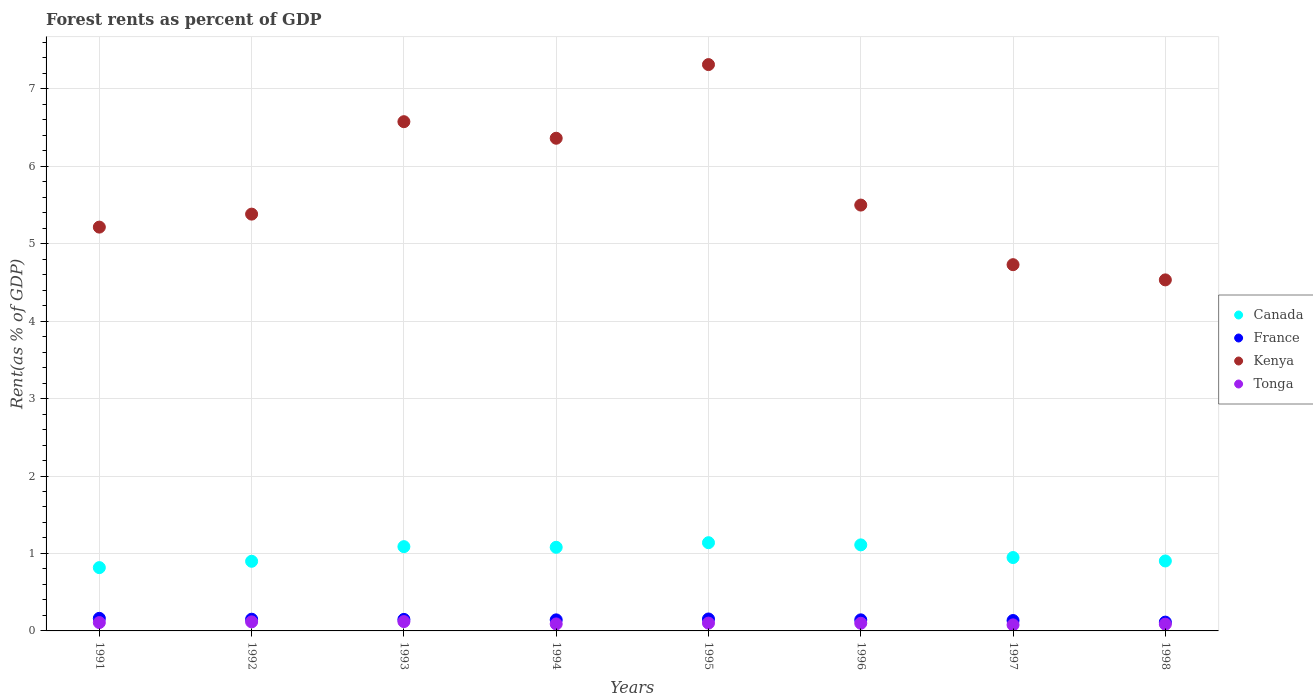Is the number of dotlines equal to the number of legend labels?
Provide a succinct answer. Yes. What is the forest rent in Canada in 1993?
Make the answer very short. 1.09. Across all years, what is the maximum forest rent in Kenya?
Your answer should be compact. 7.31. Across all years, what is the minimum forest rent in Kenya?
Offer a terse response. 4.53. In which year was the forest rent in Canada maximum?
Offer a terse response. 1995. What is the total forest rent in Kenya in the graph?
Offer a very short reply. 45.6. What is the difference between the forest rent in Kenya in 1993 and that in 1996?
Your answer should be compact. 1.08. What is the difference between the forest rent in Canada in 1992 and the forest rent in Kenya in 1996?
Offer a terse response. -4.6. What is the average forest rent in France per year?
Keep it short and to the point. 0.14. In the year 1997, what is the difference between the forest rent in Kenya and forest rent in France?
Provide a short and direct response. 4.59. What is the ratio of the forest rent in Kenya in 1996 to that in 1998?
Offer a very short reply. 1.21. Is the difference between the forest rent in Kenya in 1992 and 1994 greater than the difference between the forest rent in France in 1992 and 1994?
Ensure brevity in your answer.  No. What is the difference between the highest and the second highest forest rent in France?
Provide a succinct answer. 0.01. What is the difference between the highest and the lowest forest rent in France?
Offer a terse response. 0.05. In how many years, is the forest rent in Canada greater than the average forest rent in Canada taken over all years?
Offer a terse response. 4. Does the forest rent in Canada monotonically increase over the years?
Provide a succinct answer. No. Is the forest rent in Tonga strictly less than the forest rent in Canada over the years?
Provide a short and direct response. Yes. How many years are there in the graph?
Provide a short and direct response. 8. What is the difference between two consecutive major ticks on the Y-axis?
Your answer should be compact. 1. How many legend labels are there?
Your answer should be compact. 4. How are the legend labels stacked?
Your answer should be very brief. Vertical. What is the title of the graph?
Offer a very short reply. Forest rents as percent of GDP. What is the label or title of the X-axis?
Offer a very short reply. Years. What is the label or title of the Y-axis?
Your response must be concise. Rent(as % of GDP). What is the Rent(as % of GDP) in Canada in 1991?
Offer a very short reply. 0.82. What is the Rent(as % of GDP) in France in 1991?
Provide a short and direct response. 0.16. What is the Rent(as % of GDP) in Kenya in 1991?
Keep it short and to the point. 5.21. What is the Rent(as % of GDP) of Tonga in 1991?
Provide a short and direct response. 0.11. What is the Rent(as % of GDP) of Canada in 1992?
Provide a short and direct response. 0.9. What is the Rent(as % of GDP) in France in 1992?
Your answer should be very brief. 0.15. What is the Rent(as % of GDP) of Kenya in 1992?
Your answer should be very brief. 5.38. What is the Rent(as % of GDP) in Tonga in 1992?
Your answer should be compact. 0.12. What is the Rent(as % of GDP) in Canada in 1993?
Offer a very short reply. 1.09. What is the Rent(as % of GDP) of France in 1993?
Give a very brief answer. 0.15. What is the Rent(as % of GDP) of Kenya in 1993?
Keep it short and to the point. 6.57. What is the Rent(as % of GDP) of Tonga in 1993?
Make the answer very short. 0.12. What is the Rent(as % of GDP) of Canada in 1994?
Offer a terse response. 1.08. What is the Rent(as % of GDP) of France in 1994?
Your answer should be compact. 0.14. What is the Rent(as % of GDP) in Kenya in 1994?
Make the answer very short. 6.36. What is the Rent(as % of GDP) of Tonga in 1994?
Offer a very short reply. 0.09. What is the Rent(as % of GDP) of Canada in 1995?
Offer a terse response. 1.14. What is the Rent(as % of GDP) in France in 1995?
Your answer should be very brief. 0.15. What is the Rent(as % of GDP) of Kenya in 1995?
Give a very brief answer. 7.31. What is the Rent(as % of GDP) of Tonga in 1995?
Your answer should be very brief. 0.1. What is the Rent(as % of GDP) in Canada in 1996?
Offer a terse response. 1.11. What is the Rent(as % of GDP) in France in 1996?
Your response must be concise. 0.14. What is the Rent(as % of GDP) in Kenya in 1996?
Offer a very short reply. 5.5. What is the Rent(as % of GDP) of Tonga in 1996?
Your answer should be compact. 0.1. What is the Rent(as % of GDP) in Canada in 1997?
Offer a very short reply. 0.95. What is the Rent(as % of GDP) of France in 1997?
Provide a succinct answer. 0.13. What is the Rent(as % of GDP) in Kenya in 1997?
Your response must be concise. 4.73. What is the Rent(as % of GDP) in Tonga in 1997?
Make the answer very short. 0.08. What is the Rent(as % of GDP) in Canada in 1998?
Ensure brevity in your answer.  0.9. What is the Rent(as % of GDP) in France in 1998?
Make the answer very short. 0.11. What is the Rent(as % of GDP) in Kenya in 1998?
Provide a succinct answer. 4.53. What is the Rent(as % of GDP) of Tonga in 1998?
Make the answer very short. 0.09. Across all years, what is the maximum Rent(as % of GDP) of Canada?
Give a very brief answer. 1.14. Across all years, what is the maximum Rent(as % of GDP) in France?
Your answer should be compact. 0.16. Across all years, what is the maximum Rent(as % of GDP) in Kenya?
Make the answer very short. 7.31. Across all years, what is the maximum Rent(as % of GDP) in Tonga?
Offer a very short reply. 0.12. Across all years, what is the minimum Rent(as % of GDP) of Canada?
Provide a succinct answer. 0.82. Across all years, what is the minimum Rent(as % of GDP) in France?
Ensure brevity in your answer.  0.11. Across all years, what is the minimum Rent(as % of GDP) in Kenya?
Your response must be concise. 4.53. Across all years, what is the minimum Rent(as % of GDP) in Tonga?
Keep it short and to the point. 0.08. What is the total Rent(as % of GDP) of Canada in the graph?
Offer a terse response. 7.98. What is the total Rent(as % of GDP) in France in the graph?
Offer a very short reply. 1.15. What is the total Rent(as % of GDP) of Kenya in the graph?
Provide a succinct answer. 45.6. What is the total Rent(as % of GDP) in Tonga in the graph?
Your answer should be compact. 0.8. What is the difference between the Rent(as % of GDP) of Canada in 1991 and that in 1992?
Ensure brevity in your answer.  -0.08. What is the difference between the Rent(as % of GDP) of France in 1991 and that in 1992?
Provide a succinct answer. 0.01. What is the difference between the Rent(as % of GDP) of Kenya in 1991 and that in 1992?
Your response must be concise. -0.17. What is the difference between the Rent(as % of GDP) of Tonga in 1991 and that in 1992?
Provide a succinct answer. -0.01. What is the difference between the Rent(as % of GDP) in Canada in 1991 and that in 1993?
Ensure brevity in your answer.  -0.27. What is the difference between the Rent(as % of GDP) in France in 1991 and that in 1993?
Offer a terse response. 0.01. What is the difference between the Rent(as % of GDP) of Kenya in 1991 and that in 1993?
Offer a very short reply. -1.36. What is the difference between the Rent(as % of GDP) of Tonga in 1991 and that in 1993?
Offer a very short reply. -0.01. What is the difference between the Rent(as % of GDP) in Canada in 1991 and that in 1994?
Keep it short and to the point. -0.26. What is the difference between the Rent(as % of GDP) in France in 1991 and that in 1994?
Provide a succinct answer. 0.02. What is the difference between the Rent(as % of GDP) in Kenya in 1991 and that in 1994?
Ensure brevity in your answer.  -1.15. What is the difference between the Rent(as % of GDP) of Tonga in 1991 and that in 1994?
Provide a short and direct response. 0.02. What is the difference between the Rent(as % of GDP) in Canada in 1991 and that in 1995?
Give a very brief answer. -0.32. What is the difference between the Rent(as % of GDP) of France in 1991 and that in 1995?
Provide a short and direct response. 0.01. What is the difference between the Rent(as % of GDP) in Kenya in 1991 and that in 1995?
Keep it short and to the point. -2.1. What is the difference between the Rent(as % of GDP) in Tonga in 1991 and that in 1995?
Offer a very short reply. 0.01. What is the difference between the Rent(as % of GDP) of Canada in 1991 and that in 1996?
Offer a very short reply. -0.29. What is the difference between the Rent(as % of GDP) in France in 1991 and that in 1996?
Offer a terse response. 0.02. What is the difference between the Rent(as % of GDP) of Kenya in 1991 and that in 1996?
Make the answer very short. -0.28. What is the difference between the Rent(as % of GDP) of Tonga in 1991 and that in 1996?
Ensure brevity in your answer.  0.01. What is the difference between the Rent(as % of GDP) in Canada in 1991 and that in 1997?
Offer a terse response. -0.13. What is the difference between the Rent(as % of GDP) in France in 1991 and that in 1997?
Keep it short and to the point. 0.03. What is the difference between the Rent(as % of GDP) of Kenya in 1991 and that in 1997?
Make the answer very short. 0.48. What is the difference between the Rent(as % of GDP) in Tonga in 1991 and that in 1997?
Your answer should be very brief. 0.03. What is the difference between the Rent(as % of GDP) of Canada in 1991 and that in 1998?
Ensure brevity in your answer.  -0.09. What is the difference between the Rent(as % of GDP) in France in 1991 and that in 1998?
Ensure brevity in your answer.  0.05. What is the difference between the Rent(as % of GDP) in Kenya in 1991 and that in 1998?
Provide a short and direct response. 0.68. What is the difference between the Rent(as % of GDP) of Tonga in 1991 and that in 1998?
Offer a very short reply. 0.02. What is the difference between the Rent(as % of GDP) of Canada in 1992 and that in 1993?
Ensure brevity in your answer.  -0.19. What is the difference between the Rent(as % of GDP) in France in 1992 and that in 1993?
Offer a terse response. 0. What is the difference between the Rent(as % of GDP) in Kenya in 1992 and that in 1993?
Your answer should be compact. -1.19. What is the difference between the Rent(as % of GDP) of Tonga in 1992 and that in 1993?
Your answer should be very brief. -0. What is the difference between the Rent(as % of GDP) of Canada in 1992 and that in 1994?
Offer a terse response. -0.18. What is the difference between the Rent(as % of GDP) of France in 1992 and that in 1994?
Keep it short and to the point. 0.01. What is the difference between the Rent(as % of GDP) of Kenya in 1992 and that in 1994?
Offer a very short reply. -0.98. What is the difference between the Rent(as % of GDP) in Tonga in 1992 and that in 1994?
Keep it short and to the point. 0.03. What is the difference between the Rent(as % of GDP) of Canada in 1992 and that in 1995?
Provide a succinct answer. -0.24. What is the difference between the Rent(as % of GDP) in France in 1992 and that in 1995?
Offer a very short reply. -0. What is the difference between the Rent(as % of GDP) of Kenya in 1992 and that in 1995?
Your answer should be very brief. -1.93. What is the difference between the Rent(as % of GDP) in Tonga in 1992 and that in 1995?
Give a very brief answer. 0.02. What is the difference between the Rent(as % of GDP) of Canada in 1992 and that in 1996?
Your answer should be compact. -0.21. What is the difference between the Rent(as % of GDP) of France in 1992 and that in 1996?
Give a very brief answer. 0.01. What is the difference between the Rent(as % of GDP) in Kenya in 1992 and that in 1996?
Offer a very short reply. -0.12. What is the difference between the Rent(as % of GDP) in Tonga in 1992 and that in 1996?
Your response must be concise. 0.02. What is the difference between the Rent(as % of GDP) of Canada in 1992 and that in 1997?
Give a very brief answer. -0.05. What is the difference between the Rent(as % of GDP) in France in 1992 and that in 1997?
Keep it short and to the point. 0.02. What is the difference between the Rent(as % of GDP) in Kenya in 1992 and that in 1997?
Keep it short and to the point. 0.65. What is the difference between the Rent(as % of GDP) of Tonga in 1992 and that in 1997?
Offer a terse response. 0.04. What is the difference between the Rent(as % of GDP) of Canada in 1992 and that in 1998?
Offer a terse response. -0. What is the difference between the Rent(as % of GDP) of France in 1992 and that in 1998?
Offer a terse response. 0.04. What is the difference between the Rent(as % of GDP) in Kenya in 1992 and that in 1998?
Your answer should be compact. 0.85. What is the difference between the Rent(as % of GDP) in Tonga in 1992 and that in 1998?
Your response must be concise. 0.03. What is the difference between the Rent(as % of GDP) in Canada in 1993 and that in 1994?
Ensure brevity in your answer.  0.01. What is the difference between the Rent(as % of GDP) of France in 1993 and that in 1994?
Provide a short and direct response. 0.01. What is the difference between the Rent(as % of GDP) of Kenya in 1993 and that in 1994?
Keep it short and to the point. 0.21. What is the difference between the Rent(as % of GDP) in Tonga in 1993 and that in 1994?
Provide a short and direct response. 0.03. What is the difference between the Rent(as % of GDP) of Canada in 1993 and that in 1995?
Keep it short and to the point. -0.05. What is the difference between the Rent(as % of GDP) in France in 1993 and that in 1995?
Offer a terse response. -0.01. What is the difference between the Rent(as % of GDP) of Kenya in 1993 and that in 1995?
Keep it short and to the point. -0.74. What is the difference between the Rent(as % of GDP) of Tonga in 1993 and that in 1995?
Make the answer very short. 0.02. What is the difference between the Rent(as % of GDP) in Canada in 1993 and that in 1996?
Ensure brevity in your answer.  -0.02. What is the difference between the Rent(as % of GDP) in France in 1993 and that in 1996?
Give a very brief answer. 0.01. What is the difference between the Rent(as % of GDP) in Kenya in 1993 and that in 1996?
Offer a terse response. 1.08. What is the difference between the Rent(as % of GDP) in Tonga in 1993 and that in 1996?
Your response must be concise. 0.02. What is the difference between the Rent(as % of GDP) in Canada in 1993 and that in 1997?
Offer a terse response. 0.14. What is the difference between the Rent(as % of GDP) in France in 1993 and that in 1997?
Make the answer very short. 0.01. What is the difference between the Rent(as % of GDP) in Kenya in 1993 and that in 1997?
Ensure brevity in your answer.  1.85. What is the difference between the Rent(as % of GDP) of Tonga in 1993 and that in 1997?
Your answer should be very brief. 0.04. What is the difference between the Rent(as % of GDP) in Canada in 1993 and that in 1998?
Provide a short and direct response. 0.18. What is the difference between the Rent(as % of GDP) of France in 1993 and that in 1998?
Provide a short and direct response. 0.03. What is the difference between the Rent(as % of GDP) of Kenya in 1993 and that in 1998?
Offer a very short reply. 2.04. What is the difference between the Rent(as % of GDP) in Tonga in 1993 and that in 1998?
Ensure brevity in your answer.  0.03. What is the difference between the Rent(as % of GDP) in Canada in 1994 and that in 1995?
Provide a short and direct response. -0.06. What is the difference between the Rent(as % of GDP) in France in 1994 and that in 1995?
Provide a succinct answer. -0.01. What is the difference between the Rent(as % of GDP) of Kenya in 1994 and that in 1995?
Make the answer very short. -0.95. What is the difference between the Rent(as % of GDP) in Tonga in 1994 and that in 1995?
Ensure brevity in your answer.  -0.01. What is the difference between the Rent(as % of GDP) in Canada in 1994 and that in 1996?
Your response must be concise. -0.03. What is the difference between the Rent(as % of GDP) of France in 1994 and that in 1996?
Offer a terse response. -0. What is the difference between the Rent(as % of GDP) in Kenya in 1994 and that in 1996?
Ensure brevity in your answer.  0.86. What is the difference between the Rent(as % of GDP) of Tonga in 1994 and that in 1996?
Offer a very short reply. -0.01. What is the difference between the Rent(as % of GDP) in Canada in 1994 and that in 1997?
Make the answer very short. 0.13. What is the difference between the Rent(as % of GDP) in France in 1994 and that in 1997?
Make the answer very short. 0.01. What is the difference between the Rent(as % of GDP) in Kenya in 1994 and that in 1997?
Your answer should be very brief. 1.63. What is the difference between the Rent(as % of GDP) of Tonga in 1994 and that in 1997?
Your response must be concise. 0.01. What is the difference between the Rent(as % of GDP) of Canada in 1994 and that in 1998?
Ensure brevity in your answer.  0.18. What is the difference between the Rent(as % of GDP) in France in 1994 and that in 1998?
Make the answer very short. 0.03. What is the difference between the Rent(as % of GDP) in Kenya in 1994 and that in 1998?
Offer a terse response. 1.83. What is the difference between the Rent(as % of GDP) in Tonga in 1994 and that in 1998?
Give a very brief answer. 0. What is the difference between the Rent(as % of GDP) of Canada in 1995 and that in 1996?
Offer a very short reply. 0.03. What is the difference between the Rent(as % of GDP) of France in 1995 and that in 1996?
Keep it short and to the point. 0.01. What is the difference between the Rent(as % of GDP) of Kenya in 1995 and that in 1996?
Give a very brief answer. 1.81. What is the difference between the Rent(as % of GDP) in Tonga in 1995 and that in 1996?
Provide a short and direct response. 0. What is the difference between the Rent(as % of GDP) of Canada in 1995 and that in 1997?
Ensure brevity in your answer.  0.19. What is the difference between the Rent(as % of GDP) of France in 1995 and that in 1997?
Keep it short and to the point. 0.02. What is the difference between the Rent(as % of GDP) in Kenya in 1995 and that in 1997?
Keep it short and to the point. 2.58. What is the difference between the Rent(as % of GDP) of Tonga in 1995 and that in 1997?
Your answer should be very brief. 0.02. What is the difference between the Rent(as % of GDP) of Canada in 1995 and that in 1998?
Provide a short and direct response. 0.24. What is the difference between the Rent(as % of GDP) in France in 1995 and that in 1998?
Ensure brevity in your answer.  0.04. What is the difference between the Rent(as % of GDP) in Kenya in 1995 and that in 1998?
Ensure brevity in your answer.  2.78. What is the difference between the Rent(as % of GDP) of Tonga in 1995 and that in 1998?
Provide a short and direct response. 0.01. What is the difference between the Rent(as % of GDP) in Canada in 1996 and that in 1997?
Your response must be concise. 0.16. What is the difference between the Rent(as % of GDP) of France in 1996 and that in 1997?
Give a very brief answer. 0.01. What is the difference between the Rent(as % of GDP) of Kenya in 1996 and that in 1997?
Keep it short and to the point. 0.77. What is the difference between the Rent(as % of GDP) in Tonga in 1996 and that in 1997?
Your response must be concise. 0.02. What is the difference between the Rent(as % of GDP) of Canada in 1996 and that in 1998?
Provide a succinct answer. 0.21. What is the difference between the Rent(as % of GDP) in France in 1996 and that in 1998?
Offer a terse response. 0.03. What is the difference between the Rent(as % of GDP) of Kenya in 1996 and that in 1998?
Give a very brief answer. 0.97. What is the difference between the Rent(as % of GDP) of Tonga in 1996 and that in 1998?
Provide a succinct answer. 0.01. What is the difference between the Rent(as % of GDP) in Canada in 1997 and that in 1998?
Offer a terse response. 0.04. What is the difference between the Rent(as % of GDP) of France in 1997 and that in 1998?
Ensure brevity in your answer.  0.02. What is the difference between the Rent(as % of GDP) in Kenya in 1997 and that in 1998?
Keep it short and to the point. 0.2. What is the difference between the Rent(as % of GDP) of Tonga in 1997 and that in 1998?
Your answer should be compact. -0.01. What is the difference between the Rent(as % of GDP) in Canada in 1991 and the Rent(as % of GDP) in France in 1992?
Ensure brevity in your answer.  0.67. What is the difference between the Rent(as % of GDP) in Canada in 1991 and the Rent(as % of GDP) in Kenya in 1992?
Your answer should be compact. -4.56. What is the difference between the Rent(as % of GDP) of Canada in 1991 and the Rent(as % of GDP) of Tonga in 1992?
Make the answer very short. 0.7. What is the difference between the Rent(as % of GDP) in France in 1991 and the Rent(as % of GDP) in Kenya in 1992?
Your answer should be very brief. -5.22. What is the difference between the Rent(as % of GDP) of France in 1991 and the Rent(as % of GDP) of Tonga in 1992?
Your answer should be compact. 0.05. What is the difference between the Rent(as % of GDP) in Kenya in 1991 and the Rent(as % of GDP) in Tonga in 1992?
Make the answer very short. 5.1. What is the difference between the Rent(as % of GDP) of Canada in 1991 and the Rent(as % of GDP) of France in 1993?
Provide a succinct answer. 0.67. What is the difference between the Rent(as % of GDP) in Canada in 1991 and the Rent(as % of GDP) in Kenya in 1993?
Your answer should be compact. -5.76. What is the difference between the Rent(as % of GDP) in Canada in 1991 and the Rent(as % of GDP) in Tonga in 1993?
Keep it short and to the point. 0.7. What is the difference between the Rent(as % of GDP) in France in 1991 and the Rent(as % of GDP) in Kenya in 1993?
Your answer should be compact. -6.41. What is the difference between the Rent(as % of GDP) of France in 1991 and the Rent(as % of GDP) of Tonga in 1993?
Offer a terse response. 0.04. What is the difference between the Rent(as % of GDP) in Kenya in 1991 and the Rent(as % of GDP) in Tonga in 1993?
Give a very brief answer. 5.09. What is the difference between the Rent(as % of GDP) in Canada in 1991 and the Rent(as % of GDP) in France in 1994?
Make the answer very short. 0.67. What is the difference between the Rent(as % of GDP) of Canada in 1991 and the Rent(as % of GDP) of Kenya in 1994?
Give a very brief answer. -5.54. What is the difference between the Rent(as % of GDP) in Canada in 1991 and the Rent(as % of GDP) in Tonga in 1994?
Your answer should be very brief. 0.73. What is the difference between the Rent(as % of GDP) in France in 1991 and the Rent(as % of GDP) in Kenya in 1994?
Give a very brief answer. -6.2. What is the difference between the Rent(as % of GDP) of France in 1991 and the Rent(as % of GDP) of Tonga in 1994?
Provide a succinct answer. 0.07. What is the difference between the Rent(as % of GDP) in Kenya in 1991 and the Rent(as % of GDP) in Tonga in 1994?
Provide a short and direct response. 5.12. What is the difference between the Rent(as % of GDP) of Canada in 1991 and the Rent(as % of GDP) of France in 1995?
Give a very brief answer. 0.66. What is the difference between the Rent(as % of GDP) of Canada in 1991 and the Rent(as % of GDP) of Kenya in 1995?
Make the answer very short. -6.49. What is the difference between the Rent(as % of GDP) in Canada in 1991 and the Rent(as % of GDP) in Tonga in 1995?
Make the answer very short. 0.72. What is the difference between the Rent(as % of GDP) of France in 1991 and the Rent(as % of GDP) of Kenya in 1995?
Offer a very short reply. -7.15. What is the difference between the Rent(as % of GDP) in France in 1991 and the Rent(as % of GDP) in Tonga in 1995?
Make the answer very short. 0.06. What is the difference between the Rent(as % of GDP) of Kenya in 1991 and the Rent(as % of GDP) of Tonga in 1995?
Give a very brief answer. 5.11. What is the difference between the Rent(as % of GDP) in Canada in 1991 and the Rent(as % of GDP) in France in 1996?
Provide a short and direct response. 0.67. What is the difference between the Rent(as % of GDP) in Canada in 1991 and the Rent(as % of GDP) in Kenya in 1996?
Your answer should be very brief. -4.68. What is the difference between the Rent(as % of GDP) of Canada in 1991 and the Rent(as % of GDP) of Tonga in 1996?
Ensure brevity in your answer.  0.72. What is the difference between the Rent(as % of GDP) in France in 1991 and the Rent(as % of GDP) in Kenya in 1996?
Your answer should be compact. -5.34. What is the difference between the Rent(as % of GDP) in France in 1991 and the Rent(as % of GDP) in Tonga in 1996?
Provide a short and direct response. 0.06. What is the difference between the Rent(as % of GDP) in Kenya in 1991 and the Rent(as % of GDP) in Tonga in 1996?
Offer a very short reply. 5.11. What is the difference between the Rent(as % of GDP) of Canada in 1991 and the Rent(as % of GDP) of France in 1997?
Your response must be concise. 0.68. What is the difference between the Rent(as % of GDP) in Canada in 1991 and the Rent(as % of GDP) in Kenya in 1997?
Your response must be concise. -3.91. What is the difference between the Rent(as % of GDP) in Canada in 1991 and the Rent(as % of GDP) in Tonga in 1997?
Ensure brevity in your answer.  0.74. What is the difference between the Rent(as % of GDP) in France in 1991 and the Rent(as % of GDP) in Kenya in 1997?
Ensure brevity in your answer.  -4.57. What is the difference between the Rent(as % of GDP) of France in 1991 and the Rent(as % of GDP) of Tonga in 1997?
Offer a terse response. 0.08. What is the difference between the Rent(as % of GDP) of Kenya in 1991 and the Rent(as % of GDP) of Tonga in 1997?
Provide a succinct answer. 5.14. What is the difference between the Rent(as % of GDP) in Canada in 1991 and the Rent(as % of GDP) in France in 1998?
Your answer should be compact. 0.7. What is the difference between the Rent(as % of GDP) in Canada in 1991 and the Rent(as % of GDP) in Kenya in 1998?
Provide a succinct answer. -3.71. What is the difference between the Rent(as % of GDP) of Canada in 1991 and the Rent(as % of GDP) of Tonga in 1998?
Your answer should be compact. 0.73. What is the difference between the Rent(as % of GDP) in France in 1991 and the Rent(as % of GDP) in Kenya in 1998?
Ensure brevity in your answer.  -4.37. What is the difference between the Rent(as % of GDP) of France in 1991 and the Rent(as % of GDP) of Tonga in 1998?
Your answer should be very brief. 0.08. What is the difference between the Rent(as % of GDP) in Kenya in 1991 and the Rent(as % of GDP) in Tonga in 1998?
Ensure brevity in your answer.  5.13. What is the difference between the Rent(as % of GDP) in Canada in 1992 and the Rent(as % of GDP) in France in 1993?
Make the answer very short. 0.75. What is the difference between the Rent(as % of GDP) of Canada in 1992 and the Rent(as % of GDP) of Kenya in 1993?
Provide a succinct answer. -5.68. What is the difference between the Rent(as % of GDP) in Canada in 1992 and the Rent(as % of GDP) in Tonga in 1993?
Offer a very short reply. 0.78. What is the difference between the Rent(as % of GDP) in France in 1992 and the Rent(as % of GDP) in Kenya in 1993?
Your answer should be compact. -6.42. What is the difference between the Rent(as % of GDP) in France in 1992 and the Rent(as % of GDP) in Tonga in 1993?
Offer a very short reply. 0.03. What is the difference between the Rent(as % of GDP) in Kenya in 1992 and the Rent(as % of GDP) in Tonga in 1993?
Your answer should be compact. 5.26. What is the difference between the Rent(as % of GDP) of Canada in 1992 and the Rent(as % of GDP) of France in 1994?
Offer a very short reply. 0.76. What is the difference between the Rent(as % of GDP) in Canada in 1992 and the Rent(as % of GDP) in Kenya in 1994?
Your answer should be very brief. -5.46. What is the difference between the Rent(as % of GDP) in Canada in 1992 and the Rent(as % of GDP) in Tonga in 1994?
Provide a succinct answer. 0.81. What is the difference between the Rent(as % of GDP) of France in 1992 and the Rent(as % of GDP) of Kenya in 1994?
Your answer should be compact. -6.21. What is the difference between the Rent(as % of GDP) of France in 1992 and the Rent(as % of GDP) of Tonga in 1994?
Keep it short and to the point. 0.06. What is the difference between the Rent(as % of GDP) of Kenya in 1992 and the Rent(as % of GDP) of Tonga in 1994?
Ensure brevity in your answer.  5.29. What is the difference between the Rent(as % of GDP) in Canada in 1992 and the Rent(as % of GDP) in France in 1995?
Keep it short and to the point. 0.74. What is the difference between the Rent(as % of GDP) in Canada in 1992 and the Rent(as % of GDP) in Kenya in 1995?
Your response must be concise. -6.41. What is the difference between the Rent(as % of GDP) of Canada in 1992 and the Rent(as % of GDP) of Tonga in 1995?
Keep it short and to the point. 0.8. What is the difference between the Rent(as % of GDP) in France in 1992 and the Rent(as % of GDP) in Kenya in 1995?
Offer a terse response. -7.16. What is the difference between the Rent(as % of GDP) of France in 1992 and the Rent(as % of GDP) of Tonga in 1995?
Your answer should be very brief. 0.05. What is the difference between the Rent(as % of GDP) of Kenya in 1992 and the Rent(as % of GDP) of Tonga in 1995?
Offer a very short reply. 5.28. What is the difference between the Rent(as % of GDP) in Canada in 1992 and the Rent(as % of GDP) in France in 1996?
Offer a terse response. 0.76. What is the difference between the Rent(as % of GDP) of Canada in 1992 and the Rent(as % of GDP) of Kenya in 1996?
Provide a short and direct response. -4.6. What is the difference between the Rent(as % of GDP) of Canada in 1992 and the Rent(as % of GDP) of Tonga in 1996?
Offer a terse response. 0.8. What is the difference between the Rent(as % of GDP) of France in 1992 and the Rent(as % of GDP) of Kenya in 1996?
Provide a succinct answer. -5.35. What is the difference between the Rent(as % of GDP) of France in 1992 and the Rent(as % of GDP) of Tonga in 1996?
Provide a short and direct response. 0.05. What is the difference between the Rent(as % of GDP) of Kenya in 1992 and the Rent(as % of GDP) of Tonga in 1996?
Your answer should be very brief. 5.28. What is the difference between the Rent(as % of GDP) of Canada in 1992 and the Rent(as % of GDP) of France in 1997?
Provide a short and direct response. 0.76. What is the difference between the Rent(as % of GDP) in Canada in 1992 and the Rent(as % of GDP) in Kenya in 1997?
Give a very brief answer. -3.83. What is the difference between the Rent(as % of GDP) in Canada in 1992 and the Rent(as % of GDP) in Tonga in 1997?
Offer a very short reply. 0.82. What is the difference between the Rent(as % of GDP) of France in 1992 and the Rent(as % of GDP) of Kenya in 1997?
Offer a very short reply. -4.58. What is the difference between the Rent(as % of GDP) of France in 1992 and the Rent(as % of GDP) of Tonga in 1997?
Provide a succinct answer. 0.07. What is the difference between the Rent(as % of GDP) in Kenya in 1992 and the Rent(as % of GDP) in Tonga in 1997?
Give a very brief answer. 5.3. What is the difference between the Rent(as % of GDP) in Canada in 1992 and the Rent(as % of GDP) in France in 1998?
Offer a very short reply. 0.79. What is the difference between the Rent(as % of GDP) in Canada in 1992 and the Rent(as % of GDP) in Kenya in 1998?
Make the answer very short. -3.63. What is the difference between the Rent(as % of GDP) in Canada in 1992 and the Rent(as % of GDP) in Tonga in 1998?
Provide a succinct answer. 0.81. What is the difference between the Rent(as % of GDP) in France in 1992 and the Rent(as % of GDP) in Kenya in 1998?
Your answer should be very brief. -4.38. What is the difference between the Rent(as % of GDP) in France in 1992 and the Rent(as % of GDP) in Tonga in 1998?
Make the answer very short. 0.06. What is the difference between the Rent(as % of GDP) of Kenya in 1992 and the Rent(as % of GDP) of Tonga in 1998?
Ensure brevity in your answer.  5.29. What is the difference between the Rent(as % of GDP) of Canada in 1993 and the Rent(as % of GDP) of France in 1994?
Your answer should be compact. 0.95. What is the difference between the Rent(as % of GDP) in Canada in 1993 and the Rent(as % of GDP) in Kenya in 1994?
Give a very brief answer. -5.27. What is the difference between the Rent(as % of GDP) in France in 1993 and the Rent(as % of GDP) in Kenya in 1994?
Offer a very short reply. -6.21. What is the difference between the Rent(as % of GDP) in France in 1993 and the Rent(as % of GDP) in Tonga in 1994?
Ensure brevity in your answer.  0.06. What is the difference between the Rent(as % of GDP) in Kenya in 1993 and the Rent(as % of GDP) in Tonga in 1994?
Your answer should be compact. 6.48. What is the difference between the Rent(as % of GDP) of Canada in 1993 and the Rent(as % of GDP) of France in 1995?
Your answer should be very brief. 0.93. What is the difference between the Rent(as % of GDP) in Canada in 1993 and the Rent(as % of GDP) in Kenya in 1995?
Give a very brief answer. -6.22. What is the difference between the Rent(as % of GDP) of Canada in 1993 and the Rent(as % of GDP) of Tonga in 1995?
Keep it short and to the point. 0.99. What is the difference between the Rent(as % of GDP) in France in 1993 and the Rent(as % of GDP) in Kenya in 1995?
Your answer should be compact. -7.16. What is the difference between the Rent(as % of GDP) of France in 1993 and the Rent(as % of GDP) of Tonga in 1995?
Offer a terse response. 0.05. What is the difference between the Rent(as % of GDP) in Kenya in 1993 and the Rent(as % of GDP) in Tonga in 1995?
Your answer should be compact. 6.47. What is the difference between the Rent(as % of GDP) of Canada in 1993 and the Rent(as % of GDP) of France in 1996?
Your response must be concise. 0.95. What is the difference between the Rent(as % of GDP) of Canada in 1993 and the Rent(as % of GDP) of Kenya in 1996?
Keep it short and to the point. -4.41. What is the difference between the Rent(as % of GDP) of France in 1993 and the Rent(as % of GDP) of Kenya in 1996?
Provide a succinct answer. -5.35. What is the difference between the Rent(as % of GDP) of France in 1993 and the Rent(as % of GDP) of Tonga in 1996?
Your answer should be very brief. 0.05. What is the difference between the Rent(as % of GDP) of Kenya in 1993 and the Rent(as % of GDP) of Tonga in 1996?
Ensure brevity in your answer.  6.48. What is the difference between the Rent(as % of GDP) of Canada in 1993 and the Rent(as % of GDP) of France in 1997?
Offer a terse response. 0.95. What is the difference between the Rent(as % of GDP) of Canada in 1993 and the Rent(as % of GDP) of Kenya in 1997?
Give a very brief answer. -3.64. What is the difference between the Rent(as % of GDP) in Canada in 1993 and the Rent(as % of GDP) in Tonga in 1997?
Your response must be concise. 1.01. What is the difference between the Rent(as % of GDP) of France in 1993 and the Rent(as % of GDP) of Kenya in 1997?
Provide a short and direct response. -4.58. What is the difference between the Rent(as % of GDP) in France in 1993 and the Rent(as % of GDP) in Tonga in 1997?
Your answer should be compact. 0.07. What is the difference between the Rent(as % of GDP) in Kenya in 1993 and the Rent(as % of GDP) in Tonga in 1997?
Your answer should be compact. 6.5. What is the difference between the Rent(as % of GDP) in Canada in 1993 and the Rent(as % of GDP) in France in 1998?
Offer a terse response. 0.97. What is the difference between the Rent(as % of GDP) of Canada in 1993 and the Rent(as % of GDP) of Kenya in 1998?
Offer a very short reply. -3.44. What is the difference between the Rent(as % of GDP) in France in 1993 and the Rent(as % of GDP) in Kenya in 1998?
Make the answer very short. -4.38. What is the difference between the Rent(as % of GDP) in France in 1993 and the Rent(as % of GDP) in Tonga in 1998?
Your response must be concise. 0.06. What is the difference between the Rent(as % of GDP) in Kenya in 1993 and the Rent(as % of GDP) in Tonga in 1998?
Ensure brevity in your answer.  6.49. What is the difference between the Rent(as % of GDP) of Canada in 1994 and the Rent(as % of GDP) of France in 1995?
Offer a terse response. 0.93. What is the difference between the Rent(as % of GDP) of Canada in 1994 and the Rent(as % of GDP) of Kenya in 1995?
Keep it short and to the point. -6.23. What is the difference between the Rent(as % of GDP) in Canada in 1994 and the Rent(as % of GDP) in Tonga in 1995?
Keep it short and to the point. 0.98. What is the difference between the Rent(as % of GDP) of France in 1994 and the Rent(as % of GDP) of Kenya in 1995?
Your response must be concise. -7.17. What is the difference between the Rent(as % of GDP) of France in 1994 and the Rent(as % of GDP) of Tonga in 1995?
Your response must be concise. 0.04. What is the difference between the Rent(as % of GDP) in Kenya in 1994 and the Rent(as % of GDP) in Tonga in 1995?
Make the answer very short. 6.26. What is the difference between the Rent(as % of GDP) of Canada in 1994 and the Rent(as % of GDP) of France in 1996?
Give a very brief answer. 0.94. What is the difference between the Rent(as % of GDP) in Canada in 1994 and the Rent(as % of GDP) in Kenya in 1996?
Provide a short and direct response. -4.42. What is the difference between the Rent(as % of GDP) of Canada in 1994 and the Rent(as % of GDP) of Tonga in 1996?
Your answer should be compact. 0.98. What is the difference between the Rent(as % of GDP) of France in 1994 and the Rent(as % of GDP) of Kenya in 1996?
Your response must be concise. -5.36. What is the difference between the Rent(as % of GDP) in France in 1994 and the Rent(as % of GDP) in Tonga in 1996?
Make the answer very short. 0.04. What is the difference between the Rent(as % of GDP) in Kenya in 1994 and the Rent(as % of GDP) in Tonga in 1996?
Make the answer very short. 6.26. What is the difference between the Rent(as % of GDP) in Canada in 1994 and the Rent(as % of GDP) in France in 1997?
Offer a very short reply. 0.95. What is the difference between the Rent(as % of GDP) in Canada in 1994 and the Rent(as % of GDP) in Kenya in 1997?
Your response must be concise. -3.65. What is the difference between the Rent(as % of GDP) of France in 1994 and the Rent(as % of GDP) of Kenya in 1997?
Your answer should be very brief. -4.59. What is the difference between the Rent(as % of GDP) of France in 1994 and the Rent(as % of GDP) of Tonga in 1997?
Give a very brief answer. 0.06. What is the difference between the Rent(as % of GDP) of Kenya in 1994 and the Rent(as % of GDP) of Tonga in 1997?
Your answer should be compact. 6.28. What is the difference between the Rent(as % of GDP) in Canada in 1994 and the Rent(as % of GDP) in France in 1998?
Ensure brevity in your answer.  0.97. What is the difference between the Rent(as % of GDP) in Canada in 1994 and the Rent(as % of GDP) in Kenya in 1998?
Provide a succinct answer. -3.45. What is the difference between the Rent(as % of GDP) in Canada in 1994 and the Rent(as % of GDP) in Tonga in 1998?
Provide a succinct answer. 0.99. What is the difference between the Rent(as % of GDP) in France in 1994 and the Rent(as % of GDP) in Kenya in 1998?
Your answer should be very brief. -4.39. What is the difference between the Rent(as % of GDP) in France in 1994 and the Rent(as % of GDP) in Tonga in 1998?
Keep it short and to the point. 0.06. What is the difference between the Rent(as % of GDP) of Kenya in 1994 and the Rent(as % of GDP) of Tonga in 1998?
Keep it short and to the point. 6.27. What is the difference between the Rent(as % of GDP) in Canada in 1995 and the Rent(as % of GDP) in Kenya in 1996?
Your response must be concise. -4.36. What is the difference between the Rent(as % of GDP) in Canada in 1995 and the Rent(as % of GDP) in Tonga in 1996?
Provide a succinct answer. 1.04. What is the difference between the Rent(as % of GDP) in France in 1995 and the Rent(as % of GDP) in Kenya in 1996?
Offer a terse response. -5.34. What is the difference between the Rent(as % of GDP) of France in 1995 and the Rent(as % of GDP) of Tonga in 1996?
Keep it short and to the point. 0.06. What is the difference between the Rent(as % of GDP) of Kenya in 1995 and the Rent(as % of GDP) of Tonga in 1996?
Offer a terse response. 7.21. What is the difference between the Rent(as % of GDP) in Canada in 1995 and the Rent(as % of GDP) in Kenya in 1997?
Keep it short and to the point. -3.59. What is the difference between the Rent(as % of GDP) in Canada in 1995 and the Rent(as % of GDP) in Tonga in 1997?
Keep it short and to the point. 1.06. What is the difference between the Rent(as % of GDP) of France in 1995 and the Rent(as % of GDP) of Kenya in 1997?
Your answer should be very brief. -4.57. What is the difference between the Rent(as % of GDP) in France in 1995 and the Rent(as % of GDP) in Tonga in 1997?
Provide a short and direct response. 0.08. What is the difference between the Rent(as % of GDP) in Kenya in 1995 and the Rent(as % of GDP) in Tonga in 1997?
Make the answer very short. 7.23. What is the difference between the Rent(as % of GDP) in Canada in 1995 and the Rent(as % of GDP) in France in 1998?
Your response must be concise. 1.03. What is the difference between the Rent(as % of GDP) in Canada in 1995 and the Rent(as % of GDP) in Kenya in 1998?
Your response must be concise. -3.39. What is the difference between the Rent(as % of GDP) in Canada in 1995 and the Rent(as % of GDP) in Tonga in 1998?
Your answer should be very brief. 1.05. What is the difference between the Rent(as % of GDP) in France in 1995 and the Rent(as % of GDP) in Kenya in 1998?
Your answer should be compact. -4.38. What is the difference between the Rent(as % of GDP) in France in 1995 and the Rent(as % of GDP) in Tonga in 1998?
Offer a very short reply. 0.07. What is the difference between the Rent(as % of GDP) in Kenya in 1995 and the Rent(as % of GDP) in Tonga in 1998?
Your response must be concise. 7.22. What is the difference between the Rent(as % of GDP) of Canada in 1996 and the Rent(as % of GDP) of France in 1997?
Keep it short and to the point. 0.98. What is the difference between the Rent(as % of GDP) in Canada in 1996 and the Rent(as % of GDP) in Kenya in 1997?
Offer a terse response. -3.62. What is the difference between the Rent(as % of GDP) of Canada in 1996 and the Rent(as % of GDP) of Tonga in 1997?
Give a very brief answer. 1.03. What is the difference between the Rent(as % of GDP) of France in 1996 and the Rent(as % of GDP) of Kenya in 1997?
Your response must be concise. -4.59. What is the difference between the Rent(as % of GDP) of France in 1996 and the Rent(as % of GDP) of Tonga in 1997?
Offer a very short reply. 0.06. What is the difference between the Rent(as % of GDP) of Kenya in 1996 and the Rent(as % of GDP) of Tonga in 1997?
Offer a very short reply. 5.42. What is the difference between the Rent(as % of GDP) of Canada in 1996 and the Rent(as % of GDP) of France in 1998?
Offer a very short reply. 1. What is the difference between the Rent(as % of GDP) in Canada in 1996 and the Rent(as % of GDP) in Kenya in 1998?
Make the answer very short. -3.42. What is the difference between the Rent(as % of GDP) in Canada in 1996 and the Rent(as % of GDP) in Tonga in 1998?
Provide a succinct answer. 1.02. What is the difference between the Rent(as % of GDP) of France in 1996 and the Rent(as % of GDP) of Kenya in 1998?
Provide a succinct answer. -4.39. What is the difference between the Rent(as % of GDP) in France in 1996 and the Rent(as % of GDP) in Tonga in 1998?
Your answer should be very brief. 0.06. What is the difference between the Rent(as % of GDP) of Kenya in 1996 and the Rent(as % of GDP) of Tonga in 1998?
Provide a succinct answer. 5.41. What is the difference between the Rent(as % of GDP) of Canada in 1997 and the Rent(as % of GDP) of France in 1998?
Ensure brevity in your answer.  0.83. What is the difference between the Rent(as % of GDP) of Canada in 1997 and the Rent(as % of GDP) of Kenya in 1998?
Your response must be concise. -3.58. What is the difference between the Rent(as % of GDP) in Canada in 1997 and the Rent(as % of GDP) in Tonga in 1998?
Give a very brief answer. 0.86. What is the difference between the Rent(as % of GDP) in France in 1997 and the Rent(as % of GDP) in Kenya in 1998?
Keep it short and to the point. -4.4. What is the difference between the Rent(as % of GDP) in France in 1997 and the Rent(as % of GDP) in Tonga in 1998?
Offer a terse response. 0.05. What is the difference between the Rent(as % of GDP) of Kenya in 1997 and the Rent(as % of GDP) of Tonga in 1998?
Your answer should be very brief. 4.64. What is the average Rent(as % of GDP) of Canada per year?
Provide a succinct answer. 1. What is the average Rent(as % of GDP) of France per year?
Your answer should be compact. 0.14. What is the average Rent(as % of GDP) of Kenya per year?
Your answer should be very brief. 5.7. What is the average Rent(as % of GDP) in Tonga per year?
Your response must be concise. 0.1. In the year 1991, what is the difference between the Rent(as % of GDP) of Canada and Rent(as % of GDP) of France?
Provide a succinct answer. 0.65. In the year 1991, what is the difference between the Rent(as % of GDP) in Canada and Rent(as % of GDP) in Kenya?
Offer a terse response. -4.4. In the year 1991, what is the difference between the Rent(as % of GDP) of Canada and Rent(as % of GDP) of Tonga?
Offer a terse response. 0.71. In the year 1991, what is the difference between the Rent(as % of GDP) of France and Rent(as % of GDP) of Kenya?
Make the answer very short. -5.05. In the year 1991, what is the difference between the Rent(as % of GDP) of France and Rent(as % of GDP) of Tonga?
Your response must be concise. 0.05. In the year 1991, what is the difference between the Rent(as % of GDP) in Kenya and Rent(as % of GDP) in Tonga?
Give a very brief answer. 5.11. In the year 1992, what is the difference between the Rent(as % of GDP) in Canada and Rent(as % of GDP) in France?
Make the answer very short. 0.75. In the year 1992, what is the difference between the Rent(as % of GDP) in Canada and Rent(as % of GDP) in Kenya?
Your answer should be very brief. -4.48. In the year 1992, what is the difference between the Rent(as % of GDP) in Canada and Rent(as % of GDP) in Tonga?
Your response must be concise. 0.78. In the year 1992, what is the difference between the Rent(as % of GDP) in France and Rent(as % of GDP) in Kenya?
Provide a succinct answer. -5.23. In the year 1992, what is the difference between the Rent(as % of GDP) in France and Rent(as % of GDP) in Tonga?
Offer a terse response. 0.03. In the year 1992, what is the difference between the Rent(as % of GDP) of Kenya and Rent(as % of GDP) of Tonga?
Give a very brief answer. 5.26. In the year 1993, what is the difference between the Rent(as % of GDP) of Canada and Rent(as % of GDP) of France?
Ensure brevity in your answer.  0.94. In the year 1993, what is the difference between the Rent(as % of GDP) of Canada and Rent(as % of GDP) of Kenya?
Offer a terse response. -5.49. In the year 1993, what is the difference between the Rent(as % of GDP) of Canada and Rent(as % of GDP) of Tonga?
Your answer should be compact. 0.97. In the year 1993, what is the difference between the Rent(as % of GDP) in France and Rent(as % of GDP) in Kenya?
Your answer should be very brief. -6.43. In the year 1993, what is the difference between the Rent(as % of GDP) of France and Rent(as % of GDP) of Tonga?
Your response must be concise. 0.03. In the year 1993, what is the difference between the Rent(as % of GDP) of Kenya and Rent(as % of GDP) of Tonga?
Provide a succinct answer. 6.45. In the year 1994, what is the difference between the Rent(as % of GDP) in Canada and Rent(as % of GDP) in France?
Ensure brevity in your answer.  0.94. In the year 1994, what is the difference between the Rent(as % of GDP) of Canada and Rent(as % of GDP) of Kenya?
Ensure brevity in your answer.  -5.28. In the year 1994, what is the difference between the Rent(as % of GDP) of France and Rent(as % of GDP) of Kenya?
Provide a succinct answer. -6.22. In the year 1994, what is the difference between the Rent(as % of GDP) in France and Rent(as % of GDP) in Tonga?
Provide a short and direct response. 0.05. In the year 1994, what is the difference between the Rent(as % of GDP) in Kenya and Rent(as % of GDP) in Tonga?
Offer a terse response. 6.27. In the year 1995, what is the difference between the Rent(as % of GDP) of Canada and Rent(as % of GDP) of France?
Ensure brevity in your answer.  0.98. In the year 1995, what is the difference between the Rent(as % of GDP) in Canada and Rent(as % of GDP) in Kenya?
Your answer should be very brief. -6.17. In the year 1995, what is the difference between the Rent(as % of GDP) of Canada and Rent(as % of GDP) of Tonga?
Offer a terse response. 1.04. In the year 1995, what is the difference between the Rent(as % of GDP) of France and Rent(as % of GDP) of Kenya?
Your answer should be compact. -7.16. In the year 1995, what is the difference between the Rent(as % of GDP) of France and Rent(as % of GDP) of Tonga?
Keep it short and to the point. 0.05. In the year 1995, what is the difference between the Rent(as % of GDP) of Kenya and Rent(as % of GDP) of Tonga?
Provide a succinct answer. 7.21. In the year 1996, what is the difference between the Rent(as % of GDP) in Canada and Rent(as % of GDP) in France?
Keep it short and to the point. 0.97. In the year 1996, what is the difference between the Rent(as % of GDP) of Canada and Rent(as % of GDP) of Kenya?
Offer a very short reply. -4.39. In the year 1996, what is the difference between the Rent(as % of GDP) of Canada and Rent(as % of GDP) of Tonga?
Make the answer very short. 1.01. In the year 1996, what is the difference between the Rent(as % of GDP) of France and Rent(as % of GDP) of Kenya?
Your response must be concise. -5.36. In the year 1996, what is the difference between the Rent(as % of GDP) in France and Rent(as % of GDP) in Tonga?
Your response must be concise. 0.04. In the year 1996, what is the difference between the Rent(as % of GDP) in Kenya and Rent(as % of GDP) in Tonga?
Your answer should be compact. 5.4. In the year 1997, what is the difference between the Rent(as % of GDP) of Canada and Rent(as % of GDP) of France?
Provide a succinct answer. 0.81. In the year 1997, what is the difference between the Rent(as % of GDP) in Canada and Rent(as % of GDP) in Kenya?
Provide a short and direct response. -3.78. In the year 1997, what is the difference between the Rent(as % of GDP) of Canada and Rent(as % of GDP) of Tonga?
Your response must be concise. 0.87. In the year 1997, what is the difference between the Rent(as % of GDP) in France and Rent(as % of GDP) in Kenya?
Your answer should be very brief. -4.59. In the year 1997, what is the difference between the Rent(as % of GDP) in France and Rent(as % of GDP) in Tonga?
Give a very brief answer. 0.06. In the year 1997, what is the difference between the Rent(as % of GDP) of Kenya and Rent(as % of GDP) of Tonga?
Offer a very short reply. 4.65. In the year 1998, what is the difference between the Rent(as % of GDP) of Canada and Rent(as % of GDP) of France?
Offer a very short reply. 0.79. In the year 1998, what is the difference between the Rent(as % of GDP) in Canada and Rent(as % of GDP) in Kenya?
Keep it short and to the point. -3.63. In the year 1998, what is the difference between the Rent(as % of GDP) of Canada and Rent(as % of GDP) of Tonga?
Offer a very short reply. 0.82. In the year 1998, what is the difference between the Rent(as % of GDP) of France and Rent(as % of GDP) of Kenya?
Your answer should be compact. -4.42. In the year 1998, what is the difference between the Rent(as % of GDP) of France and Rent(as % of GDP) of Tonga?
Ensure brevity in your answer.  0.03. In the year 1998, what is the difference between the Rent(as % of GDP) in Kenya and Rent(as % of GDP) in Tonga?
Ensure brevity in your answer.  4.44. What is the ratio of the Rent(as % of GDP) of Canada in 1991 to that in 1992?
Give a very brief answer. 0.91. What is the ratio of the Rent(as % of GDP) of France in 1991 to that in 1992?
Your response must be concise. 1.08. What is the ratio of the Rent(as % of GDP) of Kenya in 1991 to that in 1992?
Provide a succinct answer. 0.97. What is the ratio of the Rent(as % of GDP) in Tonga in 1991 to that in 1992?
Your answer should be very brief. 0.92. What is the ratio of the Rent(as % of GDP) in Canada in 1991 to that in 1993?
Your response must be concise. 0.75. What is the ratio of the Rent(as % of GDP) of France in 1991 to that in 1993?
Your answer should be compact. 1.09. What is the ratio of the Rent(as % of GDP) of Kenya in 1991 to that in 1993?
Provide a succinct answer. 0.79. What is the ratio of the Rent(as % of GDP) in Tonga in 1991 to that in 1993?
Offer a terse response. 0.9. What is the ratio of the Rent(as % of GDP) of Canada in 1991 to that in 1994?
Keep it short and to the point. 0.76. What is the ratio of the Rent(as % of GDP) in France in 1991 to that in 1994?
Offer a terse response. 1.14. What is the ratio of the Rent(as % of GDP) in Kenya in 1991 to that in 1994?
Your answer should be compact. 0.82. What is the ratio of the Rent(as % of GDP) of Tonga in 1991 to that in 1994?
Ensure brevity in your answer.  1.2. What is the ratio of the Rent(as % of GDP) in Canada in 1991 to that in 1995?
Offer a very short reply. 0.72. What is the ratio of the Rent(as % of GDP) in France in 1991 to that in 1995?
Make the answer very short. 1.05. What is the ratio of the Rent(as % of GDP) in Kenya in 1991 to that in 1995?
Provide a short and direct response. 0.71. What is the ratio of the Rent(as % of GDP) of Tonga in 1991 to that in 1995?
Your answer should be compact. 1.07. What is the ratio of the Rent(as % of GDP) in Canada in 1991 to that in 1996?
Keep it short and to the point. 0.74. What is the ratio of the Rent(as % of GDP) of France in 1991 to that in 1996?
Offer a terse response. 1.14. What is the ratio of the Rent(as % of GDP) of Kenya in 1991 to that in 1996?
Give a very brief answer. 0.95. What is the ratio of the Rent(as % of GDP) of Tonga in 1991 to that in 1996?
Provide a succinct answer. 1.09. What is the ratio of the Rent(as % of GDP) of Canada in 1991 to that in 1997?
Make the answer very short. 0.86. What is the ratio of the Rent(as % of GDP) in France in 1991 to that in 1997?
Provide a short and direct response. 1.21. What is the ratio of the Rent(as % of GDP) in Kenya in 1991 to that in 1997?
Make the answer very short. 1.1. What is the ratio of the Rent(as % of GDP) of Tonga in 1991 to that in 1997?
Keep it short and to the point. 1.38. What is the ratio of the Rent(as % of GDP) in Canada in 1991 to that in 1998?
Your response must be concise. 0.9. What is the ratio of the Rent(as % of GDP) of France in 1991 to that in 1998?
Your response must be concise. 1.43. What is the ratio of the Rent(as % of GDP) in Kenya in 1991 to that in 1998?
Ensure brevity in your answer.  1.15. What is the ratio of the Rent(as % of GDP) of Tonga in 1991 to that in 1998?
Provide a succinct answer. 1.24. What is the ratio of the Rent(as % of GDP) of Canada in 1992 to that in 1993?
Your answer should be compact. 0.83. What is the ratio of the Rent(as % of GDP) of France in 1992 to that in 1993?
Offer a terse response. 1.02. What is the ratio of the Rent(as % of GDP) in Kenya in 1992 to that in 1993?
Give a very brief answer. 0.82. What is the ratio of the Rent(as % of GDP) of Tonga in 1992 to that in 1993?
Give a very brief answer. 0.97. What is the ratio of the Rent(as % of GDP) of Canada in 1992 to that in 1994?
Keep it short and to the point. 0.83. What is the ratio of the Rent(as % of GDP) in France in 1992 to that in 1994?
Your answer should be very brief. 1.06. What is the ratio of the Rent(as % of GDP) of Kenya in 1992 to that in 1994?
Provide a succinct answer. 0.85. What is the ratio of the Rent(as % of GDP) in Tonga in 1992 to that in 1994?
Make the answer very short. 1.3. What is the ratio of the Rent(as % of GDP) in Canada in 1992 to that in 1995?
Keep it short and to the point. 0.79. What is the ratio of the Rent(as % of GDP) of France in 1992 to that in 1995?
Your answer should be compact. 0.98. What is the ratio of the Rent(as % of GDP) of Kenya in 1992 to that in 1995?
Offer a very short reply. 0.74. What is the ratio of the Rent(as % of GDP) of Tonga in 1992 to that in 1995?
Make the answer very short. 1.16. What is the ratio of the Rent(as % of GDP) in Canada in 1992 to that in 1996?
Provide a succinct answer. 0.81. What is the ratio of the Rent(as % of GDP) in France in 1992 to that in 1996?
Your answer should be very brief. 1.06. What is the ratio of the Rent(as % of GDP) in Kenya in 1992 to that in 1996?
Keep it short and to the point. 0.98. What is the ratio of the Rent(as % of GDP) in Tonga in 1992 to that in 1996?
Offer a very short reply. 1.18. What is the ratio of the Rent(as % of GDP) in Canada in 1992 to that in 1997?
Offer a terse response. 0.95. What is the ratio of the Rent(as % of GDP) in France in 1992 to that in 1997?
Provide a succinct answer. 1.13. What is the ratio of the Rent(as % of GDP) of Kenya in 1992 to that in 1997?
Ensure brevity in your answer.  1.14. What is the ratio of the Rent(as % of GDP) in Tonga in 1992 to that in 1997?
Offer a terse response. 1.5. What is the ratio of the Rent(as % of GDP) in France in 1992 to that in 1998?
Keep it short and to the point. 1.33. What is the ratio of the Rent(as % of GDP) of Kenya in 1992 to that in 1998?
Make the answer very short. 1.19. What is the ratio of the Rent(as % of GDP) of Tonga in 1992 to that in 1998?
Provide a short and direct response. 1.34. What is the ratio of the Rent(as % of GDP) in Canada in 1993 to that in 1994?
Make the answer very short. 1.01. What is the ratio of the Rent(as % of GDP) in France in 1993 to that in 1994?
Provide a short and direct response. 1.04. What is the ratio of the Rent(as % of GDP) in Kenya in 1993 to that in 1994?
Provide a short and direct response. 1.03. What is the ratio of the Rent(as % of GDP) of Tonga in 1993 to that in 1994?
Make the answer very short. 1.34. What is the ratio of the Rent(as % of GDP) in Canada in 1993 to that in 1995?
Make the answer very short. 0.96. What is the ratio of the Rent(as % of GDP) of France in 1993 to that in 1995?
Make the answer very short. 0.96. What is the ratio of the Rent(as % of GDP) of Kenya in 1993 to that in 1995?
Give a very brief answer. 0.9. What is the ratio of the Rent(as % of GDP) in Tonga in 1993 to that in 1995?
Your answer should be very brief. 1.19. What is the ratio of the Rent(as % of GDP) in Canada in 1993 to that in 1996?
Provide a succinct answer. 0.98. What is the ratio of the Rent(as % of GDP) of France in 1993 to that in 1996?
Your answer should be very brief. 1.04. What is the ratio of the Rent(as % of GDP) of Kenya in 1993 to that in 1996?
Offer a terse response. 1.2. What is the ratio of the Rent(as % of GDP) of Tonga in 1993 to that in 1996?
Keep it short and to the point. 1.22. What is the ratio of the Rent(as % of GDP) of Canada in 1993 to that in 1997?
Provide a succinct answer. 1.15. What is the ratio of the Rent(as % of GDP) of France in 1993 to that in 1997?
Provide a short and direct response. 1.11. What is the ratio of the Rent(as % of GDP) of Kenya in 1993 to that in 1997?
Offer a terse response. 1.39. What is the ratio of the Rent(as % of GDP) of Tonga in 1993 to that in 1997?
Your response must be concise. 1.54. What is the ratio of the Rent(as % of GDP) of Canada in 1993 to that in 1998?
Provide a short and direct response. 1.2. What is the ratio of the Rent(as % of GDP) of France in 1993 to that in 1998?
Your answer should be very brief. 1.31. What is the ratio of the Rent(as % of GDP) in Kenya in 1993 to that in 1998?
Give a very brief answer. 1.45. What is the ratio of the Rent(as % of GDP) in Tonga in 1993 to that in 1998?
Provide a short and direct response. 1.38. What is the ratio of the Rent(as % of GDP) of Canada in 1994 to that in 1995?
Offer a terse response. 0.95. What is the ratio of the Rent(as % of GDP) of France in 1994 to that in 1995?
Give a very brief answer. 0.93. What is the ratio of the Rent(as % of GDP) of Kenya in 1994 to that in 1995?
Provide a succinct answer. 0.87. What is the ratio of the Rent(as % of GDP) of Tonga in 1994 to that in 1995?
Keep it short and to the point. 0.89. What is the ratio of the Rent(as % of GDP) of Canada in 1994 to that in 1996?
Offer a very short reply. 0.97. What is the ratio of the Rent(as % of GDP) of France in 1994 to that in 1996?
Your answer should be very brief. 1. What is the ratio of the Rent(as % of GDP) in Kenya in 1994 to that in 1996?
Your answer should be very brief. 1.16. What is the ratio of the Rent(as % of GDP) of Tonga in 1994 to that in 1996?
Your answer should be very brief. 0.91. What is the ratio of the Rent(as % of GDP) in Canada in 1994 to that in 1997?
Provide a short and direct response. 1.14. What is the ratio of the Rent(as % of GDP) in France in 1994 to that in 1997?
Keep it short and to the point. 1.06. What is the ratio of the Rent(as % of GDP) of Kenya in 1994 to that in 1997?
Keep it short and to the point. 1.35. What is the ratio of the Rent(as % of GDP) in Tonga in 1994 to that in 1997?
Offer a very short reply. 1.15. What is the ratio of the Rent(as % of GDP) in Canada in 1994 to that in 1998?
Make the answer very short. 1.2. What is the ratio of the Rent(as % of GDP) of France in 1994 to that in 1998?
Your answer should be very brief. 1.26. What is the ratio of the Rent(as % of GDP) of Kenya in 1994 to that in 1998?
Your answer should be very brief. 1.4. What is the ratio of the Rent(as % of GDP) of Tonga in 1994 to that in 1998?
Ensure brevity in your answer.  1.03. What is the ratio of the Rent(as % of GDP) in Canada in 1995 to that in 1996?
Provide a short and direct response. 1.03. What is the ratio of the Rent(as % of GDP) of France in 1995 to that in 1996?
Provide a short and direct response. 1.08. What is the ratio of the Rent(as % of GDP) of Kenya in 1995 to that in 1996?
Give a very brief answer. 1.33. What is the ratio of the Rent(as % of GDP) of Tonga in 1995 to that in 1996?
Provide a short and direct response. 1.02. What is the ratio of the Rent(as % of GDP) of Canada in 1995 to that in 1997?
Ensure brevity in your answer.  1.2. What is the ratio of the Rent(as % of GDP) in France in 1995 to that in 1997?
Offer a terse response. 1.15. What is the ratio of the Rent(as % of GDP) of Kenya in 1995 to that in 1997?
Offer a terse response. 1.55. What is the ratio of the Rent(as % of GDP) of Tonga in 1995 to that in 1997?
Offer a very short reply. 1.29. What is the ratio of the Rent(as % of GDP) of Canada in 1995 to that in 1998?
Make the answer very short. 1.26. What is the ratio of the Rent(as % of GDP) of France in 1995 to that in 1998?
Offer a very short reply. 1.36. What is the ratio of the Rent(as % of GDP) in Kenya in 1995 to that in 1998?
Provide a succinct answer. 1.61. What is the ratio of the Rent(as % of GDP) of Tonga in 1995 to that in 1998?
Offer a terse response. 1.16. What is the ratio of the Rent(as % of GDP) in Canada in 1996 to that in 1997?
Provide a succinct answer. 1.17. What is the ratio of the Rent(as % of GDP) of France in 1996 to that in 1997?
Your answer should be compact. 1.06. What is the ratio of the Rent(as % of GDP) of Kenya in 1996 to that in 1997?
Provide a short and direct response. 1.16. What is the ratio of the Rent(as % of GDP) in Tonga in 1996 to that in 1997?
Your answer should be very brief. 1.27. What is the ratio of the Rent(as % of GDP) of Canada in 1996 to that in 1998?
Your answer should be compact. 1.23. What is the ratio of the Rent(as % of GDP) of France in 1996 to that in 1998?
Give a very brief answer. 1.26. What is the ratio of the Rent(as % of GDP) of Kenya in 1996 to that in 1998?
Give a very brief answer. 1.21. What is the ratio of the Rent(as % of GDP) of Tonga in 1996 to that in 1998?
Make the answer very short. 1.13. What is the ratio of the Rent(as % of GDP) of Canada in 1997 to that in 1998?
Your answer should be very brief. 1.05. What is the ratio of the Rent(as % of GDP) in France in 1997 to that in 1998?
Provide a succinct answer. 1.18. What is the ratio of the Rent(as % of GDP) in Kenya in 1997 to that in 1998?
Your answer should be compact. 1.04. What is the ratio of the Rent(as % of GDP) in Tonga in 1997 to that in 1998?
Provide a succinct answer. 0.89. What is the difference between the highest and the second highest Rent(as % of GDP) of Canada?
Offer a terse response. 0.03. What is the difference between the highest and the second highest Rent(as % of GDP) of France?
Provide a short and direct response. 0.01. What is the difference between the highest and the second highest Rent(as % of GDP) of Kenya?
Your answer should be very brief. 0.74. What is the difference between the highest and the second highest Rent(as % of GDP) of Tonga?
Offer a terse response. 0. What is the difference between the highest and the lowest Rent(as % of GDP) in Canada?
Provide a short and direct response. 0.32. What is the difference between the highest and the lowest Rent(as % of GDP) in France?
Provide a short and direct response. 0.05. What is the difference between the highest and the lowest Rent(as % of GDP) of Kenya?
Provide a short and direct response. 2.78. What is the difference between the highest and the lowest Rent(as % of GDP) of Tonga?
Ensure brevity in your answer.  0.04. 